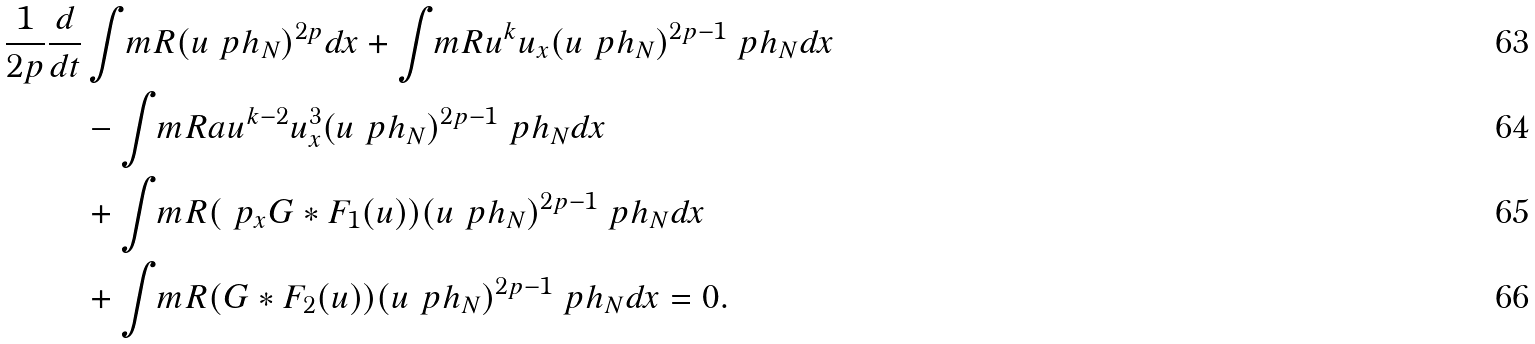Convert formula to latex. <formula><loc_0><loc_0><loc_500><loc_500>\frac { 1 } { 2 p } \frac { d } { d t } & \int _ { \ } m { R } ( u \ p h _ { N } ) ^ { 2 p } d x + \int _ { \ } m { R } u ^ { k } u _ { x } ( u \ p h _ { N } ) ^ { 2 p - 1 } \ p h _ { N } d x \\ & - \int _ { \ } m { R } a u ^ { k - 2 } u _ { x } ^ { 3 } ( u \ p h _ { N } ) ^ { 2 p - 1 } \ p h _ { N } d x \\ & + \int _ { \ } m { R } ( \ p _ { x } G * F _ { 1 } ( u ) ) ( u \ p h _ { N } ) ^ { 2 p - 1 } \ p h _ { N } d x \\ & + \int _ { \ } m { R } ( G * F _ { 2 } ( u ) ) ( u \ p h _ { N } ) ^ { 2 p - 1 } \ p h _ { N } d x = 0 .</formula> 